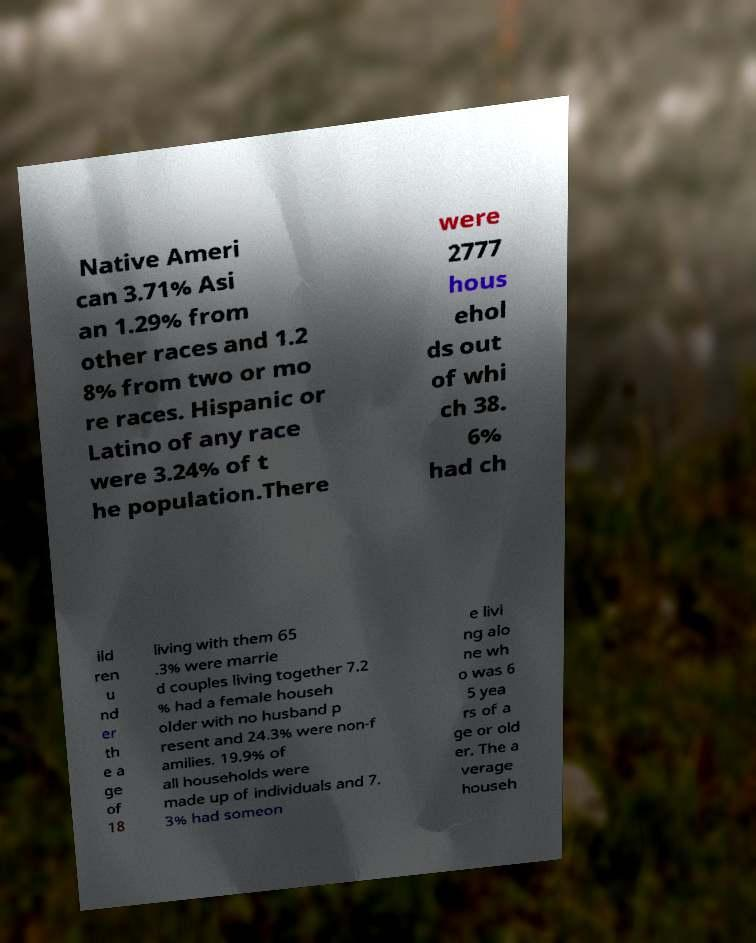What messages or text are displayed in this image? I need them in a readable, typed format. Native Ameri can 3.71% Asi an 1.29% from other races and 1.2 8% from two or mo re races. Hispanic or Latino of any race were 3.24% of t he population.There were 2777 hous ehol ds out of whi ch 38. 6% had ch ild ren u nd er th e a ge of 18 living with them 65 .3% were marrie d couples living together 7.2 % had a female househ older with no husband p resent and 24.3% were non-f amilies. 19.9% of all households were made up of individuals and 7. 3% had someon e livi ng alo ne wh o was 6 5 yea rs of a ge or old er. The a verage househ 